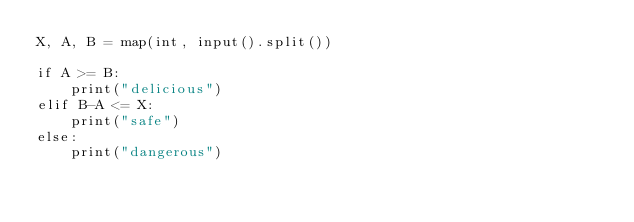Convert code to text. <code><loc_0><loc_0><loc_500><loc_500><_Python_>X, A, B = map(int, input().split())

if A >= B:
    print("delicious")
elif B-A <= X:
    print("safe")
else:
    print("dangerous")</code> 